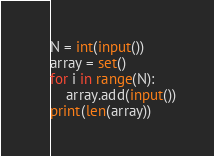Convert code to text. <code><loc_0><loc_0><loc_500><loc_500><_Python_>N = int(input())
array = set()
for i in range(N):
    array.add(input())
print(len(array))
</code> 